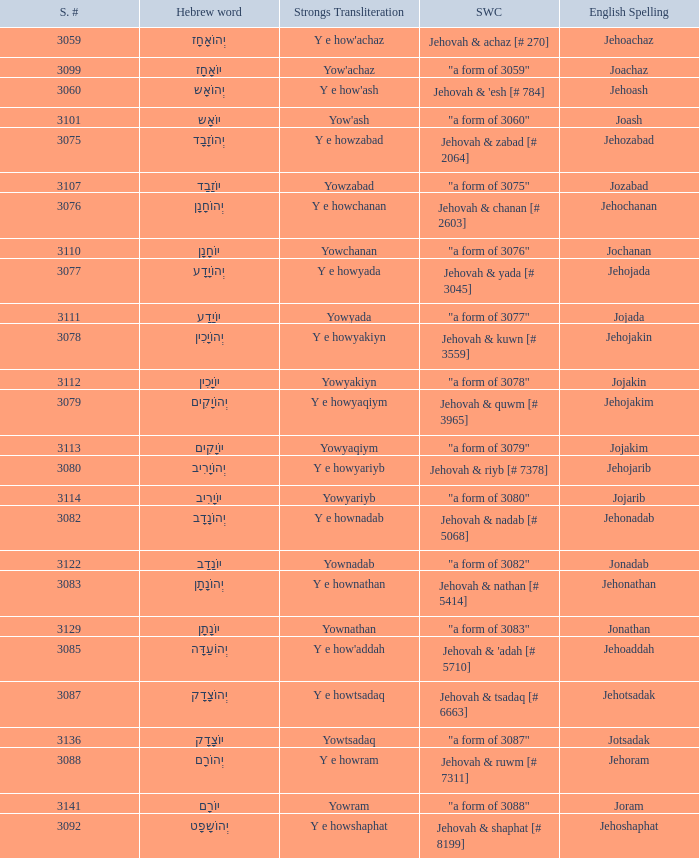What is the english spelling of the word that has the strongs trasliteration of y e howram? Jehoram. Could you help me parse every detail presented in this table? {'header': ['S. #', 'Hebrew word', 'Strongs Transliteration', 'SWC', 'English Spelling'], 'rows': [['3059', 'יְהוֹאָחָז', "Y e how'achaz", 'Jehovah & achaz [# 270]', 'Jehoachaz'], ['3099', 'יוֹאָחָז', "Yow'achaz", '"a form of 3059"', 'Joachaz'], ['3060', 'יְהוֹאָש', "Y e how'ash", "Jehovah & 'esh [# 784]", 'Jehoash'], ['3101', 'יוֹאָש', "Yow'ash", '"a form of 3060"', 'Joash'], ['3075', 'יְהוֹזָבָד', 'Y e howzabad', 'Jehovah & zabad [# 2064]', 'Jehozabad'], ['3107', 'יוֹזָבָד', 'Yowzabad', '"a form of 3075"', 'Jozabad'], ['3076', 'יְהוֹחָנָן', 'Y e howchanan', 'Jehovah & chanan [# 2603]', 'Jehochanan'], ['3110', 'יוֹחָנָן', 'Yowchanan', '"a form of 3076"', 'Jochanan'], ['3077', 'יְהוֹיָדָע', 'Y e howyada', 'Jehovah & yada [# 3045]', 'Jehojada'], ['3111', 'יוֹיָדָע', 'Yowyada', '"a form of 3077"', 'Jojada'], ['3078', 'יְהוֹיָכִין', 'Y e howyakiyn', 'Jehovah & kuwn [# 3559]', 'Jehojakin'], ['3112', 'יוֹיָכִין', 'Yowyakiyn', '"a form of 3078"', 'Jojakin'], ['3079', 'יְהוֹיָקִים', 'Y e howyaqiym', 'Jehovah & quwm [# 3965]', 'Jehojakim'], ['3113', 'יוֹיָקִים', 'Yowyaqiym', '"a form of 3079"', 'Jojakim'], ['3080', 'יְהוֹיָרִיב', 'Y e howyariyb', 'Jehovah & riyb [# 7378]', 'Jehojarib'], ['3114', 'יוֹיָרִיב', 'Yowyariyb', '"a form of 3080"', 'Jojarib'], ['3082', 'יְהוֹנָדָב', 'Y e hownadab', 'Jehovah & nadab [# 5068]', 'Jehonadab'], ['3122', 'יוֹנָדָב', 'Yownadab', '"a form of 3082"', 'Jonadab'], ['3083', 'יְהוֹנָתָן', 'Y e hownathan', 'Jehovah & nathan [# 5414]', 'Jehonathan'], ['3129', 'יוֹנָתָן', 'Yownathan', '"a form of 3083"', 'Jonathan'], ['3085', 'יְהוֹעַדָּה', "Y e how'addah", "Jehovah & 'adah [# 5710]", 'Jehoaddah'], ['3087', 'יְהוֹצָדָק', 'Y e howtsadaq', 'Jehovah & tsadaq [# 6663]', 'Jehotsadak'], ['3136', 'יוֹצָדָק', 'Yowtsadaq', '"a form of 3087"', 'Jotsadak'], ['3088', 'יְהוֹרָם', 'Y e howram', 'Jehovah & ruwm [# 7311]', 'Jehoram'], ['3141', 'יוֹרָם', 'Yowram', '"a form of 3088"', 'Joram'], ['3092', 'יְהוֹשָפָט', 'Y e howshaphat', 'Jehovah & shaphat [# 8199]', 'Jehoshaphat']]} 